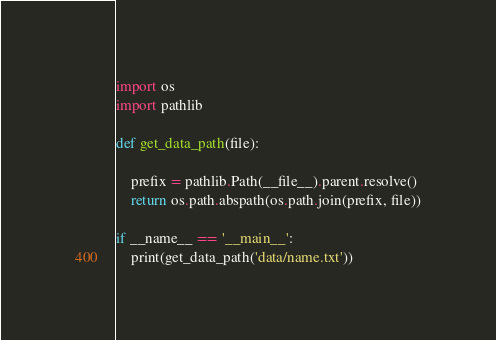<code> <loc_0><loc_0><loc_500><loc_500><_Python_>import os
import pathlib

def get_data_path(file):

    prefix = pathlib.Path(__file__).parent.resolve()
    return os.path.abspath(os.path.join(prefix, file))

if __name__ == '__main__':
    print(get_data_path('data/name.txt'))</code> 